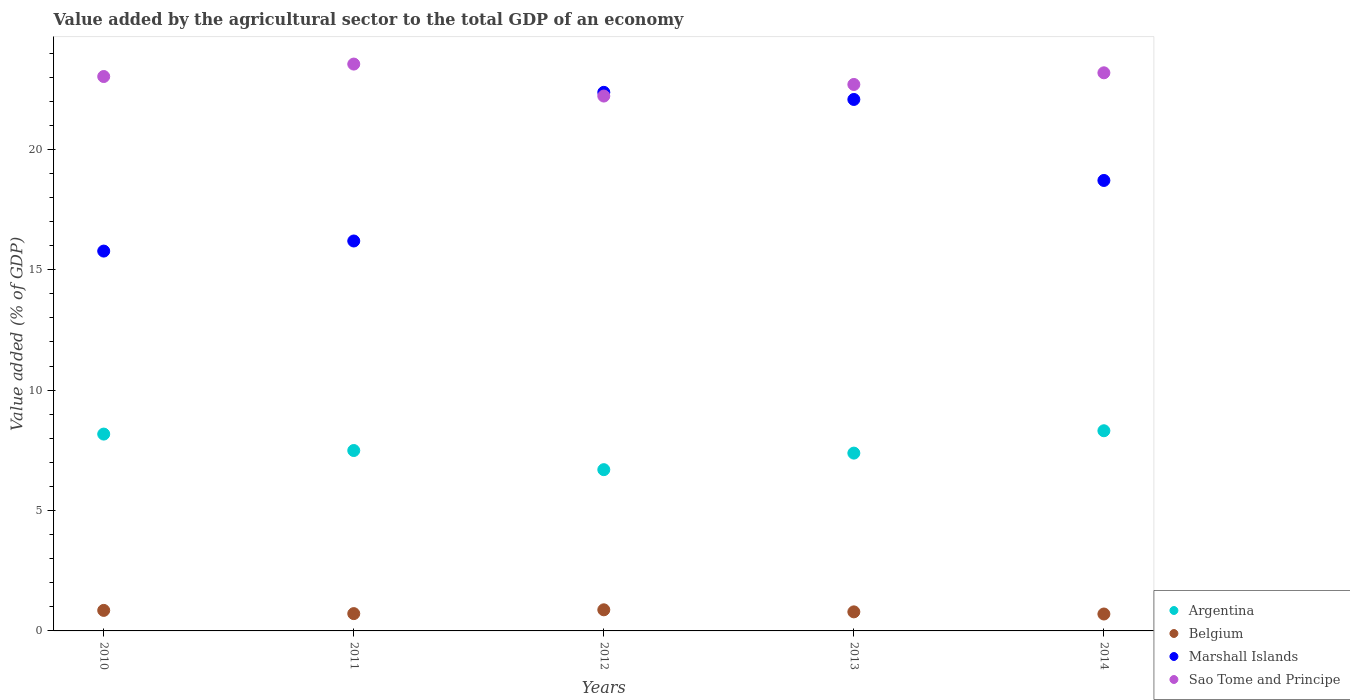Is the number of dotlines equal to the number of legend labels?
Ensure brevity in your answer.  Yes. What is the value added by the agricultural sector to the total GDP in Belgium in 2010?
Your answer should be compact. 0.85. Across all years, what is the maximum value added by the agricultural sector to the total GDP in Belgium?
Your response must be concise. 0.88. Across all years, what is the minimum value added by the agricultural sector to the total GDP in Belgium?
Your answer should be compact. 0.7. What is the total value added by the agricultural sector to the total GDP in Argentina in the graph?
Provide a succinct answer. 38.06. What is the difference between the value added by the agricultural sector to the total GDP in Sao Tome and Principe in 2013 and that in 2014?
Provide a short and direct response. -0.48. What is the difference between the value added by the agricultural sector to the total GDP in Marshall Islands in 2013 and the value added by the agricultural sector to the total GDP in Argentina in 2014?
Give a very brief answer. 13.76. What is the average value added by the agricultural sector to the total GDP in Sao Tome and Principe per year?
Your answer should be very brief. 22.93. In the year 2013, what is the difference between the value added by the agricultural sector to the total GDP in Marshall Islands and value added by the agricultural sector to the total GDP in Argentina?
Provide a short and direct response. 14.69. In how many years, is the value added by the agricultural sector to the total GDP in Belgium greater than 4 %?
Make the answer very short. 0. What is the ratio of the value added by the agricultural sector to the total GDP in Belgium in 2010 to that in 2011?
Offer a terse response. 1.19. Is the difference between the value added by the agricultural sector to the total GDP in Marshall Islands in 2010 and 2012 greater than the difference between the value added by the agricultural sector to the total GDP in Argentina in 2010 and 2012?
Keep it short and to the point. No. What is the difference between the highest and the second highest value added by the agricultural sector to the total GDP in Belgium?
Offer a terse response. 0.02. What is the difference between the highest and the lowest value added by the agricultural sector to the total GDP in Belgium?
Your response must be concise. 0.17. Is the sum of the value added by the agricultural sector to the total GDP in Sao Tome and Principe in 2010 and 2012 greater than the maximum value added by the agricultural sector to the total GDP in Argentina across all years?
Give a very brief answer. Yes. Does the value added by the agricultural sector to the total GDP in Marshall Islands monotonically increase over the years?
Your answer should be compact. No. Is the value added by the agricultural sector to the total GDP in Marshall Islands strictly less than the value added by the agricultural sector to the total GDP in Argentina over the years?
Your answer should be very brief. No. How many dotlines are there?
Make the answer very short. 4. How many years are there in the graph?
Ensure brevity in your answer.  5. What is the difference between two consecutive major ticks on the Y-axis?
Keep it short and to the point. 5. Are the values on the major ticks of Y-axis written in scientific E-notation?
Your response must be concise. No. Does the graph contain grids?
Offer a very short reply. No. Where does the legend appear in the graph?
Provide a short and direct response. Bottom right. What is the title of the graph?
Provide a short and direct response. Value added by the agricultural sector to the total GDP of an economy. Does "Arab World" appear as one of the legend labels in the graph?
Your response must be concise. No. What is the label or title of the Y-axis?
Offer a very short reply. Value added (% of GDP). What is the Value added (% of GDP) of Argentina in 2010?
Provide a succinct answer. 8.18. What is the Value added (% of GDP) of Belgium in 2010?
Your answer should be very brief. 0.85. What is the Value added (% of GDP) of Marshall Islands in 2010?
Your answer should be compact. 15.78. What is the Value added (% of GDP) in Sao Tome and Principe in 2010?
Your response must be concise. 23.03. What is the Value added (% of GDP) of Argentina in 2011?
Offer a very short reply. 7.49. What is the Value added (% of GDP) of Belgium in 2011?
Provide a short and direct response. 0.72. What is the Value added (% of GDP) of Marshall Islands in 2011?
Offer a very short reply. 16.19. What is the Value added (% of GDP) of Sao Tome and Principe in 2011?
Offer a very short reply. 23.54. What is the Value added (% of GDP) of Argentina in 2012?
Offer a terse response. 6.7. What is the Value added (% of GDP) of Belgium in 2012?
Offer a terse response. 0.88. What is the Value added (% of GDP) in Marshall Islands in 2012?
Give a very brief answer. 22.37. What is the Value added (% of GDP) of Sao Tome and Principe in 2012?
Give a very brief answer. 22.21. What is the Value added (% of GDP) of Argentina in 2013?
Offer a very short reply. 7.38. What is the Value added (% of GDP) in Belgium in 2013?
Provide a short and direct response. 0.79. What is the Value added (% of GDP) of Marshall Islands in 2013?
Your answer should be very brief. 22.07. What is the Value added (% of GDP) in Sao Tome and Principe in 2013?
Provide a short and direct response. 22.7. What is the Value added (% of GDP) in Argentina in 2014?
Keep it short and to the point. 8.31. What is the Value added (% of GDP) in Belgium in 2014?
Give a very brief answer. 0.7. What is the Value added (% of GDP) of Marshall Islands in 2014?
Provide a short and direct response. 18.71. What is the Value added (% of GDP) in Sao Tome and Principe in 2014?
Give a very brief answer. 23.18. Across all years, what is the maximum Value added (% of GDP) of Argentina?
Give a very brief answer. 8.31. Across all years, what is the maximum Value added (% of GDP) of Belgium?
Offer a terse response. 0.88. Across all years, what is the maximum Value added (% of GDP) in Marshall Islands?
Make the answer very short. 22.37. Across all years, what is the maximum Value added (% of GDP) of Sao Tome and Principe?
Make the answer very short. 23.54. Across all years, what is the minimum Value added (% of GDP) of Argentina?
Provide a succinct answer. 6.7. Across all years, what is the minimum Value added (% of GDP) of Belgium?
Ensure brevity in your answer.  0.7. Across all years, what is the minimum Value added (% of GDP) in Marshall Islands?
Give a very brief answer. 15.78. Across all years, what is the minimum Value added (% of GDP) in Sao Tome and Principe?
Your answer should be very brief. 22.21. What is the total Value added (% of GDP) of Argentina in the graph?
Provide a short and direct response. 38.06. What is the total Value added (% of GDP) in Belgium in the graph?
Provide a succinct answer. 3.94. What is the total Value added (% of GDP) in Marshall Islands in the graph?
Your response must be concise. 95.12. What is the total Value added (% of GDP) in Sao Tome and Principe in the graph?
Give a very brief answer. 114.66. What is the difference between the Value added (% of GDP) in Argentina in 2010 and that in 2011?
Provide a short and direct response. 0.68. What is the difference between the Value added (% of GDP) in Belgium in 2010 and that in 2011?
Your answer should be very brief. 0.13. What is the difference between the Value added (% of GDP) of Marshall Islands in 2010 and that in 2011?
Offer a terse response. -0.42. What is the difference between the Value added (% of GDP) of Sao Tome and Principe in 2010 and that in 2011?
Ensure brevity in your answer.  -0.52. What is the difference between the Value added (% of GDP) in Argentina in 2010 and that in 2012?
Offer a terse response. 1.48. What is the difference between the Value added (% of GDP) of Belgium in 2010 and that in 2012?
Give a very brief answer. -0.02. What is the difference between the Value added (% of GDP) of Marshall Islands in 2010 and that in 2012?
Offer a very short reply. -6.59. What is the difference between the Value added (% of GDP) in Sao Tome and Principe in 2010 and that in 2012?
Keep it short and to the point. 0.81. What is the difference between the Value added (% of GDP) in Argentina in 2010 and that in 2013?
Make the answer very short. 0.79. What is the difference between the Value added (% of GDP) in Belgium in 2010 and that in 2013?
Offer a terse response. 0.06. What is the difference between the Value added (% of GDP) in Marshall Islands in 2010 and that in 2013?
Your answer should be compact. -6.3. What is the difference between the Value added (% of GDP) in Sao Tome and Principe in 2010 and that in 2013?
Offer a terse response. 0.33. What is the difference between the Value added (% of GDP) in Argentina in 2010 and that in 2014?
Offer a terse response. -0.14. What is the difference between the Value added (% of GDP) of Marshall Islands in 2010 and that in 2014?
Your answer should be very brief. -2.93. What is the difference between the Value added (% of GDP) in Sao Tome and Principe in 2010 and that in 2014?
Offer a terse response. -0.15. What is the difference between the Value added (% of GDP) in Argentina in 2011 and that in 2012?
Your answer should be compact. 0.8. What is the difference between the Value added (% of GDP) of Belgium in 2011 and that in 2012?
Give a very brief answer. -0.16. What is the difference between the Value added (% of GDP) of Marshall Islands in 2011 and that in 2012?
Offer a very short reply. -6.17. What is the difference between the Value added (% of GDP) of Sao Tome and Principe in 2011 and that in 2012?
Your answer should be compact. 1.33. What is the difference between the Value added (% of GDP) of Argentina in 2011 and that in 2013?
Offer a very short reply. 0.11. What is the difference between the Value added (% of GDP) in Belgium in 2011 and that in 2013?
Make the answer very short. -0.07. What is the difference between the Value added (% of GDP) of Marshall Islands in 2011 and that in 2013?
Keep it short and to the point. -5.88. What is the difference between the Value added (% of GDP) in Sao Tome and Principe in 2011 and that in 2013?
Keep it short and to the point. 0.85. What is the difference between the Value added (% of GDP) of Argentina in 2011 and that in 2014?
Provide a short and direct response. -0.82. What is the difference between the Value added (% of GDP) of Belgium in 2011 and that in 2014?
Keep it short and to the point. 0.02. What is the difference between the Value added (% of GDP) in Marshall Islands in 2011 and that in 2014?
Keep it short and to the point. -2.51. What is the difference between the Value added (% of GDP) of Sao Tome and Principe in 2011 and that in 2014?
Provide a short and direct response. 0.36. What is the difference between the Value added (% of GDP) of Argentina in 2012 and that in 2013?
Ensure brevity in your answer.  -0.69. What is the difference between the Value added (% of GDP) in Belgium in 2012 and that in 2013?
Ensure brevity in your answer.  0.09. What is the difference between the Value added (% of GDP) in Marshall Islands in 2012 and that in 2013?
Provide a succinct answer. 0.3. What is the difference between the Value added (% of GDP) of Sao Tome and Principe in 2012 and that in 2013?
Ensure brevity in your answer.  -0.48. What is the difference between the Value added (% of GDP) in Argentina in 2012 and that in 2014?
Offer a very short reply. -1.62. What is the difference between the Value added (% of GDP) in Belgium in 2012 and that in 2014?
Offer a terse response. 0.17. What is the difference between the Value added (% of GDP) in Marshall Islands in 2012 and that in 2014?
Offer a very short reply. 3.66. What is the difference between the Value added (% of GDP) in Sao Tome and Principe in 2012 and that in 2014?
Provide a short and direct response. -0.97. What is the difference between the Value added (% of GDP) in Argentina in 2013 and that in 2014?
Provide a succinct answer. -0.93. What is the difference between the Value added (% of GDP) in Belgium in 2013 and that in 2014?
Provide a succinct answer. 0.09. What is the difference between the Value added (% of GDP) in Marshall Islands in 2013 and that in 2014?
Keep it short and to the point. 3.36. What is the difference between the Value added (% of GDP) of Sao Tome and Principe in 2013 and that in 2014?
Make the answer very short. -0.48. What is the difference between the Value added (% of GDP) in Argentina in 2010 and the Value added (% of GDP) in Belgium in 2011?
Offer a terse response. 7.46. What is the difference between the Value added (% of GDP) in Argentina in 2010 and the Value added (% of GDP) in Marshall Islands in 2011?
Offer a terse response. -8.02. What is the difference between the Value added (% of GDP) in Argentina in 2010 and the Value added (% of GDP) in Sao Tome and Principe in 2011?
Your answer should be compact. -15.37. What is the difference between the Value added (% of GDP) in Belgium in 2010 and the Value added (% of GDP) in Marshall Islands in 2011?
Offer a terse response. -15.34. What is the difference between the Value added (% of GDP) in Belgium in 2010 and the Value added (% of GDP) in Sao Tome and Principe in 2011?
Make the answer very short. -22.69. What is the difference between the Value added (% of GDP) of Marshall Islands in 2010 and the Value added (% of GDP) of Sao Tome and Principe in 2011?
Keep it short and to the point. -7.77. What is the difference between the Value added (% of GDP) of Argentina in 2010 and the Value added (% of GDP) of Belgium in 2012?
Keep it short and to the point. 7.3. What is the difference between the Value added (% of GDP) in Argentina in 2010 and the Value added (% of GDP) in Marshall Islands in 2012?
Your response must be concise. -14.19. What is the difference between the Value added (% of GDP) of Argentina in 2010 and the Value added (% of GDP) of Sao Tome and Principe in 2012?
Your response must be concise. -14.04. What is the difference between the Value added (% of GDP) in Belgium in 2010 and the Value added (% of GDP) in Marshall Islands in 2012?
Keep it short and to the point. -21.52. What is the difference between the Value added (% of GDP) in Belgium in 2010 and the Value added (% of GDP) in Sao Tome and Principe in 2012?
Make the answer very short. -21.36. What is the difference between the Value added (% of GDP) in Marshall Islands in 2010 and the Value added (% of GDP) in Sao Tome and Principe in 2012?
Your answer should be compact. -6.44. What is the difference between the Value added (% of GDP) in Argentina in 2010 and the Value added (% of GDP) in Belgium in 2013?
Offer a very short reply. 7.38. What is the difference between the Value added (% of GDP) of Argentina in 2010 and the Value added (% of GDP) of Marshall Islands in 2013?
Make the answer very short. -13.9. What is the difference between the Value added (% of GDP) of Argentina in 2010 and the Value added (% of GDP) of Sao Tome and Principe in 2013?
Your answer should be very brief. -14.52. What is the difference between the Value added (% of GDP) in Belgium in 2010 and the Value added (% of GDP) in Marshall Islands in 2013?
Your answer should be very brief. -21.22. What is the difference between the Value added (% of GDP) of Belgium in 2010 and the Value added (% of GDP) of Sao Tome and Principe in 2013?
Give a very brief answer. -21.84. What is the difference between the Value added (% of GDP) in Marshall Islands in 2010 and the Value added (% of GDP) in Sao Tome and Principe in 2013?
Give a very brief answer. -6.92. What is the difference between the Value added (% of GDP) of Argentina in 2010 and the Value added (% of GDP) of Belgium in 2014?
Your response must be concise. 7.47. What is the difference between the Value added (% of GDP) of Argentina in 2010 and the Value added (% of GDP) of Marshall Islands in 2014?
Ensure brevity in your answer.  -10.53. What is the difference between the Value added (% of GDP) in Argentina in 2010 and the Value added (% of GDP) in Sao Tome and Principe in 2014?
Your answer should be very brief. -15. What is the difference between the Value added (% of GDP) of Belgium in 2010 and the Value added (% of GDP) of Marshall Islands in 2014?
Keep it short and to the point. -17.86. What is the difference between the Value added (% of GDP) in Belgium in 2010 and the Value added (% of GDP) in Sao Tome and Principe in 2014?
Make the answer very short. -22.33. What is the difference between the Value added (% of GDP) in Marshall Islands in 2010 and the Value added (% of GDP) in Sao Tome and Principe in 2014?
Keep it short and to the point. -7.4. What is the difference between the Value added (% of GDP) of Argentina in 2011 and the Value added (% of GDP) of Belgium in 2012?
Your answer should be compact. 6.62. What is the difference between the Value added (% of GDP) of Argentina in 2011 and the Value added (% of GDP) of Marshall Islands in 2012?
Make the answer very short. -14.88. What is the difference between the Value added (% of GDP) of Argentina in 2011 and the Value added (% of GDP) of Sao Tome and Principe in 2012?
Keep it short and to the point. -14.72. What is the difference between the Value added (% of GDP) of Belgium in 2011 and the Value added (% of GDP) of Marshall Islands in 2012?
Your response must be concise. -21.65. What is the difference between the Value added (% of GDP) in Belgium in 2011 and the Value added (% of GDP) in Sao Tome and Principe in 2012?
Your answer should be very brief. -21.5. What is the difference between the Value added (% of GDP) of Marshall Islands in 2011 and the Value added (% of GDP) of Sao Tome and Principe in 2012?
Your answer should be compact. -6.02. What is the difference between the Value added (% of GDP) of Argentina in 2011 and the Value added (% of GDP) of Belgium in 2013?
Your response must be concise. 6.7. What is the difference between the Value added (% of GDP) in Argentina in 2011 and the Value added (% of GDP) in Marshall Islands in 2013?
Offer a very short reply. -14.58. What is the difference between the Value added (% of GDP) of Argentina in 2011 and the Value added (% of GDP) of Sao Tome and Principe in 2013?
Keep it short and to the point. -15.2. What is the difference between the Value added (% of GDP) in Belgium in 2011 and the Value added (% of GDP) in Marshall Islands in 2013?
Keep it short and to the point. -21.35. What is the difference between the Value added (% of GDP) in Belgium in 2011 and the Value added (% of GDP) in Sao Tome and Principe in 2013?
Ensure brevity in your answer.  -21.98. What is the difference between the Value added (% of GDP) of Marshall Islands in 2011 and the Value added (% of GDP) of Sao Tome and Principe in 2013?
Provide a short and direct response. -6.5. What is the difference between the Value added (% of GDP) of Argentina in 2011 and the Value added (% of GDP) of Belgium in 2014?
Ensure brevity in your answer.  6.79. What is the difference between the Value added (% of GDP) in Argentina in 2011 and the Value added (% of GDP) in Marshall Islands in 2014?
Keep it short and to the point. -11.22. What is the difference between the Value added (% of GDP) of Argentina in 2011 and the Value added (% of GDP) of Sao Tome and Principe in 2014?
Ensure brevity in your answer.  -15.69. What is the difference between the Value added (% of GDP) of Belgium in 2011 and the Value added (% of GDP) of Marshall Islands in 2014?
Keep it short and to the point. -17.99. What is the difference between the Value added (% of GDP) in Belgium in 2011 and the Value added (% of GDP) in Sao Tome and Principe in 2014?
Offer a terse response. -22.46. What is the difference between the Value added (% of GDP) in Marshall Islands in 2011 and the Value added (% of GDP) in Sao Tome and Principe in 2014?
Give a very brief answer. -6.99. What is the difference between the Value added (% of GDP) in Argentina in 2012 and the Value added (% of GDP) in Belgium in 2013?
Your answer should be very brief. 5.91. What is the difference between the Value added (% of GDP) of Argentina in 2012 and the Value added (% of GDP) of Marshall Islands in 2013?
Your answer should be compact. -15.38. What is the difference between the Value added (% of GDP) in Argentina in 2012 and the Value added (% of GDP) in Sao Tome and Principe in 2013?
Give a very brief answer. -16. What is the difference between the Value added (% of GDP) in Belgium in 2012 and the Value added (% of GDP) in Marshall Islands in 2013?
Provide a succinct answer. -21.2. What is the difference between the Value added (% of GDP) in Belgium in 2012 and the Value added (% of GDP) in Sao Tome and Principe in 2013?
Offer a very short reply. -21.82. What is the difference between the Value added (% of GDP) in Marshall Islands in 2012 and the Value added (% of GDP) in Sao Tome and Principe in 2013?
Provide a short and direct response. -0.33. What is the difference between the Value added (% of GDP) of Argentina in 2012 and the Value added (% of GDP) of Belgium in 2014?
Offer a very short reply. 5.99. What is the difference between the Value added (% of GDP) in Argentina in 2012 and the Value added (% of GDP) in Marshall Islands in 2014?
Provide a short and direct response. -12.01. What is the difference between the Value added (% of GDP) in Argentina in 2012 and the Value added (% of GDP) in Sao Tome and Principe in 2014?
Your answer should be compact. -16.48. What is the difference between the Value added (% of GDP) of Belgium in 2012 and the Value added (% of GDP) of Marshall Islands in 2014?
Provide a succinct answer. -17.83. What is the difference between the Value added (% of GDP) in Belgium in 2012 and the Value added (% of GDP) in Sao Tome and Principe in 2014?
Offer a terse response. -22.3. What is the difference between the Value added (% of GDP) of Marshall Islands in 2012 and the Value added (% of GDP) of Sao Tome and Principe in 2014?
Give a very brief answer. -0.81. What is the difference between the Value added (% of GDP) in Argentina in 2013 and the Value added (% of GDP) in Belgium in 2014?
Your answer should be compact. 6.68. What is the difference between the Value added (% of GDP) of Argentina in 2013 and the Value added (% of GDP) of Marshall Islands in 2014?
Offer a very short reply. -11.32. What is the difference between the Value added (% of GDP) in Argentina in 2013 and the Value added (% of GDP) in Sao Tome and Principe in 2014?
Your response must be concise. -15.8. What is the difference between the Value added (% of GDP) in Belgium in 2013 and the Value added (% of GDP) in Marshall Islands in 2014?
Ensure brevity in your answer.  -17.92. What is the difference between the Value added (% of GDP) of Belgium in 2013 and the Value added (% of GDP) of Sao Tome and Principe in 2014?
Provide a short and direct response. -22.39. What is the difference between the Value added (% of GDP) of Marshall Islands in 2013 and the Value added (% of GDP) of Sao Tome and Principe in 2014?
Your answer should be very brief. -1.11. What is the average Value added (% of GDP) of Argentina per year?
Provide a succinct answer. 7.61. What is the average Value added (% of GDP) in Belgium per year?
Offer a very short reply. 0.79. What is the average Value added (% of GDP) in Marshall Islands per year?
Provide a succinct answer. 19.02. What is the average Value added (% of GDP) in Sao Tome and Principe per year?
Your answer should be very brief. 22.93. In the year 2010, what is the difference between the Value added (% of GDP) of Argentina and Value added (% of GDP) of Belgium?
Give a very brief answer. 7.32. In the year 2010, what is the difference between the Value added (% of GDP) in Argentina and Value added (% of GDP) in Marshall Islands?
Your answer should be very brief. -7.6. In the year 2010, what is the difference between the Value added (% of GDP) in Argentina and Value added (% of GDP) in Sao Tome and Principe?
Offer a terse response. -14.85. In the year 2010, what is the difference between the Value added (% of GDP) in Belgium and Value added (% of GDP) in Marshall Islands?
Your answer should be very brief. -14.92. In the year 2010, what is the difference between the Value added (% of GDP) of Belgium and Value added (% of GDP) of Sao Tome and Principe?
Keep it short and to the point. -22.17. In the year 2010, what is the difference between the Value added (% of GDP) of Marshall Islands and Value added (% of GDP) of Sao Tome and Principe?
Offer a very short reply. -7.25. In the year 2011, what is the difference between the Value added (% of GDP) of Argentina and Value added (% of GDP) of Belgium?
Offer a terse response. 6.77. In the year 2011, what is the difference between the Value added (% of GDP) in Argentina and Value added (% of GDP) in Marshall Islands?
Offer a very short reply. -8.7. In the year 2011, what is the difference between the Value added (% of GDP) in Argentina and Value added (% of GDP) in Sao Tome and Principe?
Your response must be concise. -16.05. In the year 2011, what is the difference between the Value added (% of GDP) of Belgium and Value added (% of GDP) of Marshall Islands?
Make the answer very short. -15.48. In the year 2011, what is the difference between the Value added (% of GDP) in Belgium and Value added (% of GDP) in Sao Tome and Principe?
Your response must be concise. -22.82. In the year 2011, what is the difference between the Value added (% of GDP) of Marshall Islands and Value added (% of GDP) of Sao Tome and Principe?
Your answer should be compact. -7.35. In the year 2012, what is the difference between the Value added (% of GDP) in Argentina and Value added (% of GDP) in Belgium?
Provide a short and direct response. 5.82. In the year 2012, what is the difference between the Value added (% of GDP) in Argentina and Value added (% of GDP) in Marshall Islands?
Keep it short and to the point. -15.67. In the year 2012, what is the difference between the Value added (% of GDP) of Argentina and Value added (% of GDP) of Sao Tome and Principe?
Offer a very short reply. -15.52. In the year 2012, what is the difference between the Value added (% of GDP) in Belgium and Value added (% of GDP) in Marshall Islands?
Provide a succinct answer. -21.49. In the year 2012, what is the difference between the Value added (% of GDP) of Belgium and Value added (% of GDP) of Sao Tome and Principe?
Offer a very short reply. -21.34. In the year 2012, what is the difference between the Value added (% of GDP) of Marshall Islands and Value added (% of GDP) of Sao Tome and Principe?
Your answer should be very brief. 0.15. In the year 2013, what is the difference between the Value added (% of GDP) of Argentina and Value added (% of GDP) of Belgium?
Provide a succinct answer. 6.59. In the year 2013, what is the difference between the Value added (% of GDP) of Argentina and Value added (% of GDP) of Marshall Islands?
Your response must be concise. -14.69. In the year 2013, what is the difference between the Value added (% of GDP) of Argentina and Value added (% of GDP) of Sao Tome and Principe?
Keep it short and to the point. -15.31. In the year 2013, what is the difference between the Value added (% of GDP) of Belgium and Value added (% of GDP) of Marshall Islands?
Ensure brevity in your answer.  -21.28. In the year 2013, what is the difference between the Value added (% of GDP) in Belgium and Value added (% of GDP) in Sao Tome and Principe?
Your response must be concise. -21.9. In the year 2013, what is the difference between the Value added (% of GDP) of Marshall Islands and Value added (% of GDP) of Sao Tome and Principe?
Keep it short and to the point. -0.62. In the year 2014, what is the difference between the Value added (% of GDP) in Argentina and Value added (% of GDP) in Belgium?
Your answer should be very brief. 7.61. In the year 2014, what is the difference between the Value added (% of GDP) in Argentina and Value added (% of GDP) in Marshall Islands?
Your answer should be very brief. -10.4. In the year 2014, what is the difference between the Value added (% of GDP) in Argentina and Value added (% of GDP) in Sao Tome and Principe?
Provide a succinct answer. -14.87. In the year 2014, what is the difference between the Value added (% of GDP) of Belgium and Value added (% of GDP) of Marshall Islands?
Your answer should be very brief. -18.01. In the year 2014, what is the difference between the Value added (% of GDP) of Belgium and Value added (% of GDP) of Sao Tome and Principe?
Keep it short and to the point. -22.48. In the year 2014, what is the difference between the Value added (% of GDP) in Marshall Islands and Value added (% of GDP) in Sao Tome and Principe?
Provide a succinct answer. -4.47. What is the ratio of the Value added (% of GDP) of Argentina in 2010 to that in 2011?
Your answer should be compact. 1.09. What is the ratio of the Value added (% of GDP) of Belgium in 2010 to that in 2011?
Give a very brief answer. 1.19. What is the ratio of the Value added (% of GDP) of Marshall Islands in 2010 to that in 2011?
Give a very brief answer. 0.97. What is the ratio of the Value added (% of GDP) of Sao Tome and Principe in 2010 to that in 2011?
Offer a very short reply. 0.98. What is the ratio of the Value added (% of GDP) in Argentina in 2010 to that in 2012?
Your answer should be very brief. 1.22. What is the ratio of the Value added (% of GDP) of Belgium in 2010 to that in 2012?
Your answer should be compact. 0.97. What is the ratio of the Value added (% of GDP) in Marshall Islands in 2010 to that in 2012?
Give a very brief answer. 0.71. What is the ratio of the Value added (% of GDP) of Sao Tome and Principe in 2010 to that in 2012?
Your response must be concise. 1.04. What is the ratio of the Value added (% of GDP) in Argentina in 2010 to that in 2013?
Provide a short and direct response. 1.11. What is the ratio of the Value added (% of GDP) in Belgium in 2010 to that in 2013?
Offer a terse response. 1.08. What is the ratio of the Value added (% of GDP) in Marshall Islands in 2010 to that in 2013?
Give a very brief answer. 0.71. What is the ratio of the Value added (% of GDP) in Sao Tome and Principe in 2010 to that in 2013?
Provide a succinct answer. 1.01. What is the ratio of the Value added (% of GDP) in Argentina in 2010 to that in 2014?
Offer a very short reply. 0.98. What is the ratio of the Value added (% of GDP) in Belgium in 2010 to that in 2014?
Give a very brief answer. 1.21. What is the ratio of the Value added (% of GDP) in Marshall Islands in 2010 to that in 2014?
Keep it short and to the point. 0.84. What is the ratio of the Value added (% of GDP) in Argentina in 2011 to that in 2012?
Provide a succinct answer. 1.12. What is the ratio of the Value added (% of GDP) of Belgium in 2011 to that in 2012?
Provide a short and direct response. 0.82. What is the ratio of the Value added (% of GDP) in Marshall Islands in 2011 to that in 2012?
Your answer should be compact. 0.72. What is the ratio of the Value added (% of GDP) of Sao Tome and Principe in 2011 to that in 2012?
Your response must be concise. 1.06. What is the ratio of the Value added (% of GDP) of Argentina in 2011 to that in 2013?
Make the answer very short. 1.01. What is the ratio of the Value added (% of GDP) of Belgium in 2011 to that in 2013?
Offer a terse response. 0.91. What is the ratio of the Value added (% of GDP) of Marshall Islands in 2011 to that in 2013?
Provide a short and direct response. 0.73. What is the ratio of the Value added (% of GDP) in Sao Tome and Principe in 2011 to that in 2013?
Give a very brief answer. 1.04. What is the ratio of the Value added (% of GDP) of Argentina in 2011 to that in 2014?
Offer a terse response. 0.9. What is the ratio of the Value added (% of GDP) in Belgium in 2011 to that in 2014?
Offer a terse response. 1.02. What is the ratio of the Value added (% of GDP) in Marshall Islands in 2011 to that in 2014?
Provide a short and direct response. 0.87. What is the ratio of the Value added (% of GDP) in Sao Tome and Principe in 2011 to that in 2014?
Keep it short and to the point. 1.02. What is the ratio of the Value added (% of GDP) in Argentina in 2012 to that in 2013?
Offer a terse response. 0.91. What is the ratio of the Value added (% of GDP) of Belgium in 2012 to that in 2013?
Your response must be concise. 1.11. What is the ratio of the Value added (% of GDP) of Marshall Islands in 2012 to that in 2013?
Provide a short and direct response. 1.01. What is the ratio of the Value added (% of GDP) in Sao Tome and Principe in 2012 to that in 2013?
Keep it short and to the point. 0.98. What is the ratio of the Value added (% of GDP) of Argentina in 2012 to that in 2014?
Your response must be concise. 0.81. What is the ratio of the Value added (% of GDP) in Belgium in 2012 to that in 2014?
Your response must be concise. 1.25. What is the ratio of the Value added (% of GDP) in Marshall Islands in 2012 to that in 2014?
Offer a very short reply. 1.2. What is the ratio of the Value added (% of GDP) of Argentina in 2013 to that in 2014?
Your answer should be compact. 0.89. What is the ratio of the Value added (% of GDP) in Belgium in 2013 to that in 2014?
Provide a short and direct response. 1.13. What is the ratio of the Value added (% of GDP) of Marshall Islands in 2013 to that in 2014?
Give a very brief answer. 1.18. What is the ratio of the Value added (% of GDP) of Sao Tome and Principe in 2013 to that in 2014?
Your answer should be compact. 0.98. What is the difference between the highest and the second highest Value added (% of GDP) of Argentina?
Your response must be concise. 0.14. What is the difference between the highest and the second highest Value added (% of GDP) in Belgium?
Your answer should be very brief. 0.02. What is the difference between the highest and the second highest Value added (% of GDP) in Marshall Islands?
Offer a terse response. 0.3. What is the difference between the highest and the second highest Value added (% of GDP) of Sao Tome and Principe?
Give a very brief answer. 0.36. What is the difference between the highest and the lowest Value added (% of GDP) of Argentina?
Your response must be concise. 1.62. What is the difference between the highest and the lowest Value added (% of GDP) of Belgium?
Your answer should be very brief. 0.17. What is the difference between the highest and the lowest Value added (% of GDP) of Marshall Islands?
Keep it short and to the point. 6.59. What is the difference between the highest and the lowest Value added (% of GDP) of Sao Tome and Principe?
Ensure brevity in your answer.  1.33. 